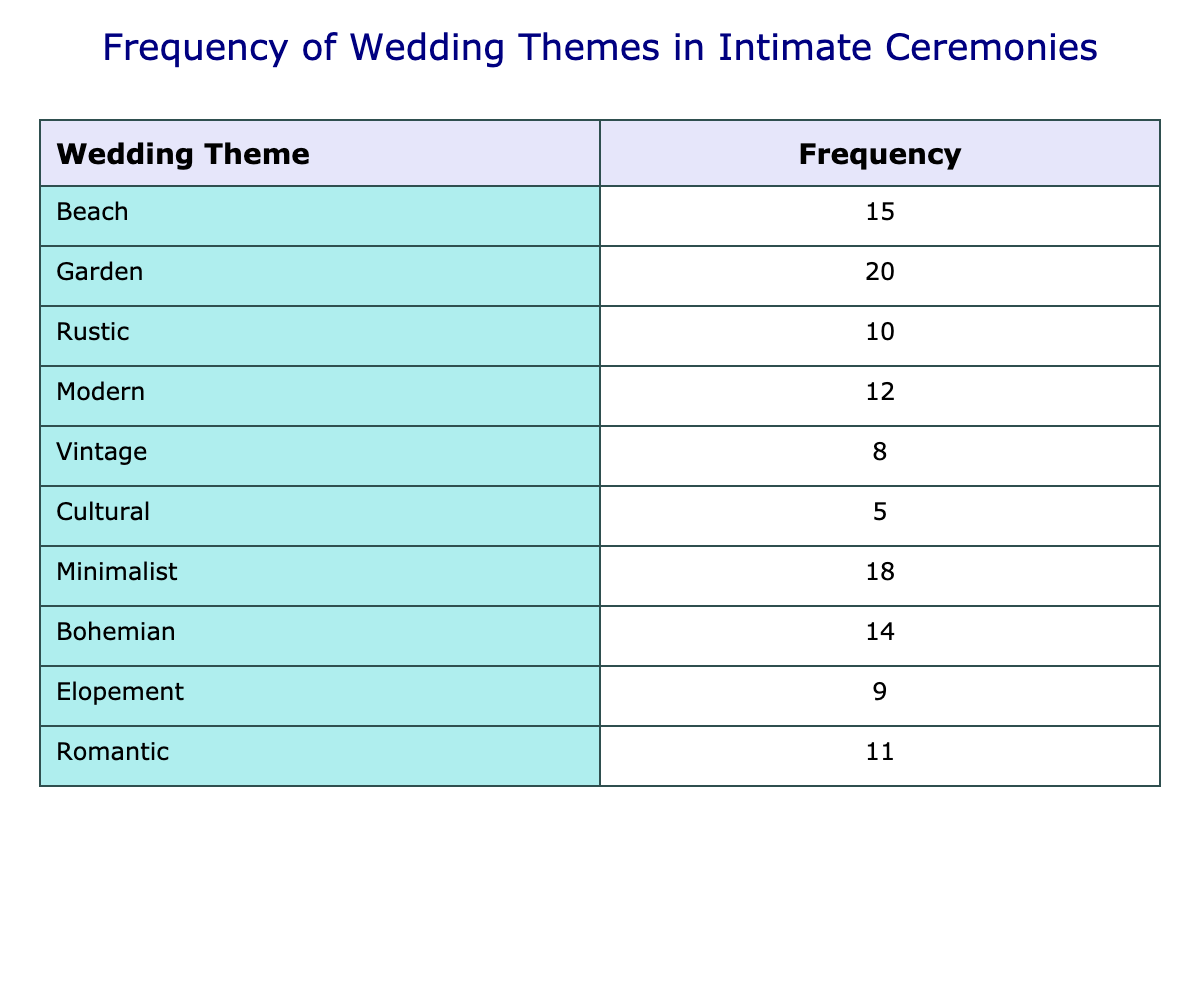What is the most chosen wedding theme? By examining the Frequency column, we can see that "Garden" has the highest frequency of 20, meaning it is the most chosen wedding theme.
Answer: Garden What is the least chosen wedding theme? Looking at the table, "Cultural" has the lowest frequency of 5, indicating it is the least chosen wedding theme.
Answer: Cultural How many wedding themes have a frequency greater than 10? By checking the Frequency column, the themes with frequency greater than 10 are Beach (15), Garden (20), Modern (12), Minimalist (18), Bohemian (14), and Romantic (11). This gives us a total of 6 themes.
Answer: 6 What is the total frequency of all wedding themes combined? Adding the frequencies of all themes: 15 + 20 + 10 + 12 + 8 + 5 + 18 + 14 + 9 + 11 = 132. Therefore, the total frequency is 132.
Answer: 132 If we remove the top two most chosen themes, what would be the new total frequency? The top two themes are Garden (20) and Beach (15), so we remove these frequencies: 132 - 20 - 15 = 97. Thus, the new total frequency would be 97.
Answer: 97 Is there any theme that is chosen exactly 10 times? Checking the table, "Rustic" is chosen exactly 10 times, which confirms that there is indeed a theme with that frequency.
Answer: Yes What is the difference in frequency between the most chosen and the least chosen themes? The most chosen theme is Garden with a frequency of 20, and the least chosen theme is Cultural with a frequency of 5. The difference is 20 - 5 = 15.
Answer: 15 Which wedding theme is selected closest to the average frequency? First, calculate the average frequency: 132 total frequency / 10 total themes = 13.2. The themes closest to this are Modern (12) and Minimalist (18). Minimalist is the closest on the higher side, while Modern is the closest on the lower side.
Answer: Minimalist and Modern If you group the themes into those with a frequency of 15 or more and those with less than 15, how many themes belong to each group? The themes with a frequency of 15 or more are Garden (20), Beach (15), Minimalist (18), and Bohemian (14), totaling 4. The themes with less than 15 are Rustic (10), Vintage (8), Cultural (5), Elopement (9), and Romantic (11), totaling 6 themes.
Answer: 4 and 6 